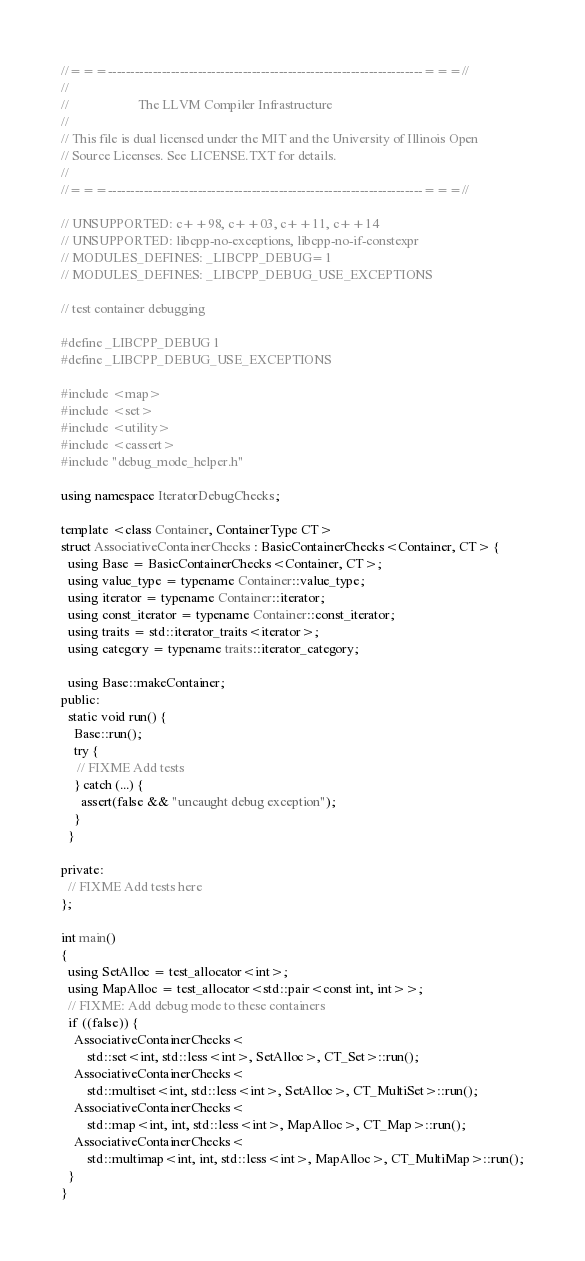Convert code to text. <code><loc_0><loc_0><loc_500><loc_500><_C++_>//===----------------------------------------------------------------------===//
//
//                     The LLVM Compiler Infrastructure
//
// This file is dual licensed under the MIT and the University of Illinois Open
// Source Licenses. See LICENSE.TXT for details.
//
//===----------------------------------------------------------------------===//

// UNSUPPORTED: c++98, c++03, c++11, c++14
// UNSUPPORTED: libcpp-no-exceptions, libcpp-no-if-constexpr
// MODULES_DEFINES: _LIBCPP_DEBUG=1
// MODULES_DEFINES: _LIBCPP_DEBUG_USE_EXCEPTIONS

// test container debugging

#define _LIBCPP_DEBUG 1
#define _LIBCPP_DEBUG_USE_EXCEPTIONS

#include <map>
#include <set>
#include <utility>
#include <cassert>
#include "debug_mode_helper.h"

using namespace IteratorDebugChecks;

template <class Container, ContainerType CT>
struct AssociativeContainerChecks : BasicContainerChecks<Container, CT> {
  using Base = BasicContainerChecks<Container, CT>;
  using value_type = typename Container::value_type;
  using iterator = typename Container::iterator;
  using const_iterator = typename Container::const_iterator;
  using traits = std::iterator_traits<iterator>;
  using category = typename traits::iterator_category;

  using Base::makeContainer;
public:
  static void run() {
    Base::run();
    try {
     // FIXME Add tests
    } catch (...) {
      assert(false && "uncaught debug exception");
    }
  }

private:
  // FIXME Add tests here
};

int main()
{
  using SetAlloc = test_allocator<int>;
  using MapAlloc = test_allocator<std::pair<const int, int>>;
  // FIXME: Add debug mode to these containers
  if ((false)) {
    AssociativeContainerChecks<
        std::set<int, std::less<int>, SetAlloc>, CT_Set>::run();
    AssociativeContainerChecks<
        std::multiset<int, std::less<int>, SetAlloc>, CT_MultiSet>::run();
    AssociativeContainerChecks<
        std::map<int, int, std::less<int>, MapAlloc>, CT_Map>::run();
    AssociativeContainerChecks<
        std::multimap<int, int, std::less<int>, MapAlloc>, CT_MultiMap>::run();
  }
}
</code> 